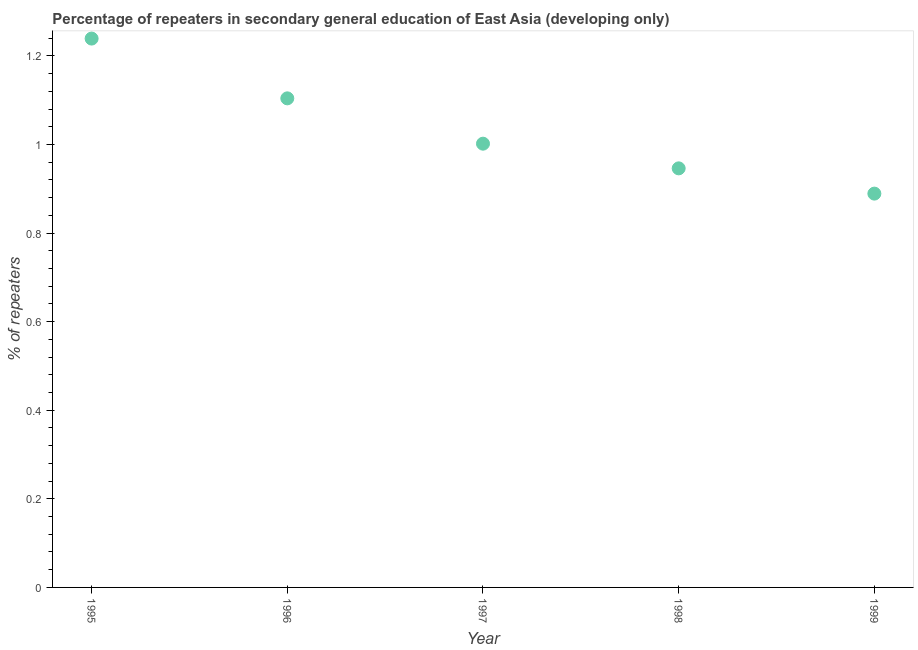What is the percentage of repeaters in 1995?
Provide a succinct answer. 1.24. Across all years, what is the maximum percentage of repeaters?
Provide a succinct answer. 1.24. Across all years, what is the minimum percentage of repeaters?
Make the answer very short. 0.89. In which year was the percentage of repeaters minimum?
Your answer should be compact. 1999. What is the sum of the percentage of repeaters?
Your answer should be compact. 5.18. What is the difference between the percentage of repeaters in 1995 and 1999?
Ensure brevity in your answer.  0.35. What is the average percentage of repeaters per year?
Offer a very short reply. 1.04. What is the median percentage of repeaters?
Your answer should be compact. 1. In how many years, is the percentage of repeaters greater than 1 %?
Keep it short and to the point. 3. Do a majority of the years between 1997 and 1996 (inclusive) have percentage of repeaters greater than 0.9600000000000001 %?
Your answer should be compact. No. What is the ratio of the percentage of repeaters in 1997 to that in 1999?
Offer a terse response. 1.13. Is the percentage of repeaters in 1997 less than that in 1998?
Provide a short and direct response. No. What is the difference between the highest and the second highest percentage of repeaters?
Your answer should be compact. 0.13. Is the sum of the percentage of repeaters in 1995 and 1998 greater than the maximum percentage of repeaters across all years?
Your answer should be compact. Yes. What is the difference between the highest and the lowest percentage of repeaters?
Make the answer very short. 0.35. How many dotlines are there?
Give a very brief answer. 1. Are the values on the major ticks of Y-axis written in scientific E-notation?
Give a very brief answer. No. Does the graph contain any zero values?
Your answer should be compact. No. What is the title of the graph?
Your response must be concise. Percentage of repeaters in secondary general education of East Asia (developing only). What is the label or title of the Y-axis?
Give a very brief answer. % of repeaters. What is the % of repeaters in 1995?
Keep it short and to the point. 1.24. What is the % of repeaters in 1996?
Your response must be concise. 1.1. What is the % of repeaters in 1997?
Your response must be concise. 1. What is the % of repeaters in 1998?
Provide a short and direct response. 0.95. What is the % of repeaters in 1999?
Give a very brief answer. 0.89. What is the difference between the % of repeaters in 1995 and 1996?
Offer a terse response. 0.13. What is the difference between the % of repeaters in 1995 and 1997?
Keep it short and to the point. 0.24. What is the difference between the % of repeaters in 1995 and 1998?
Offer a very short reply. 0.29. What is the difference between the % of repeaters in 1995 and 1999?
Offer a very short reply. 0.35. What is the difference between the % of repeaters in 1996 and 1997?
Give a very brief answer. 0.1. What is the difference between the % of repeaters in 1996 and 1998?
Offer a very short reply. 0.16. What is the difference between the % of repeaters in 1996 and 1999?
Your response must be concise. 0.22. What is the difference between the % of repeaters in 1997 and 1998?
Keep it short and to the point. 0.06. What is the difference between the % of repeaters in 1997 and 1999?
Your answer should be compact. 0.11. What is the difference between the % of repeaters in 1998 and 1999?
Your answer should be very brief. 0.06. What is the ratio of the % of repeaters in 1995 to that in 1996?
Keep it short and to the point. 1.12. What is the ratio of the % of repeaters in 1995 to that in 1997?
Keep it short and to the point. 1.24. What is the ratio of the % of repeaters in 1995 to that in 1998?
Provide a short and direct response. 1.31. What is the ratio of the % of repeaters in 1995 to that in 1999?
Give a very brief answer. 1.39. What is the ratio of the % of repeaters in 1996 to that in 1997?
Provide a short and direct response. 1.1. What is the ratio of the % of repeaters in 1996 to that in 1998?
Ensure brevity in your answer.  1.17. What is the ratio of the % of repeaters in 1996 to that in 1999?
Keep it short and to the point. 1.24. What is the ratio of the % of repeaters in 1997 to that in 1998?
Offer a very short reply. 1.06. What is the ratio of the % of repeaters in 1997 to that in 1999?
Your answer should be very brief. 1.13. What is the ratio of the % of repeaters in 1998 to that in 1999?
Give a very brief answer. 1.06. 